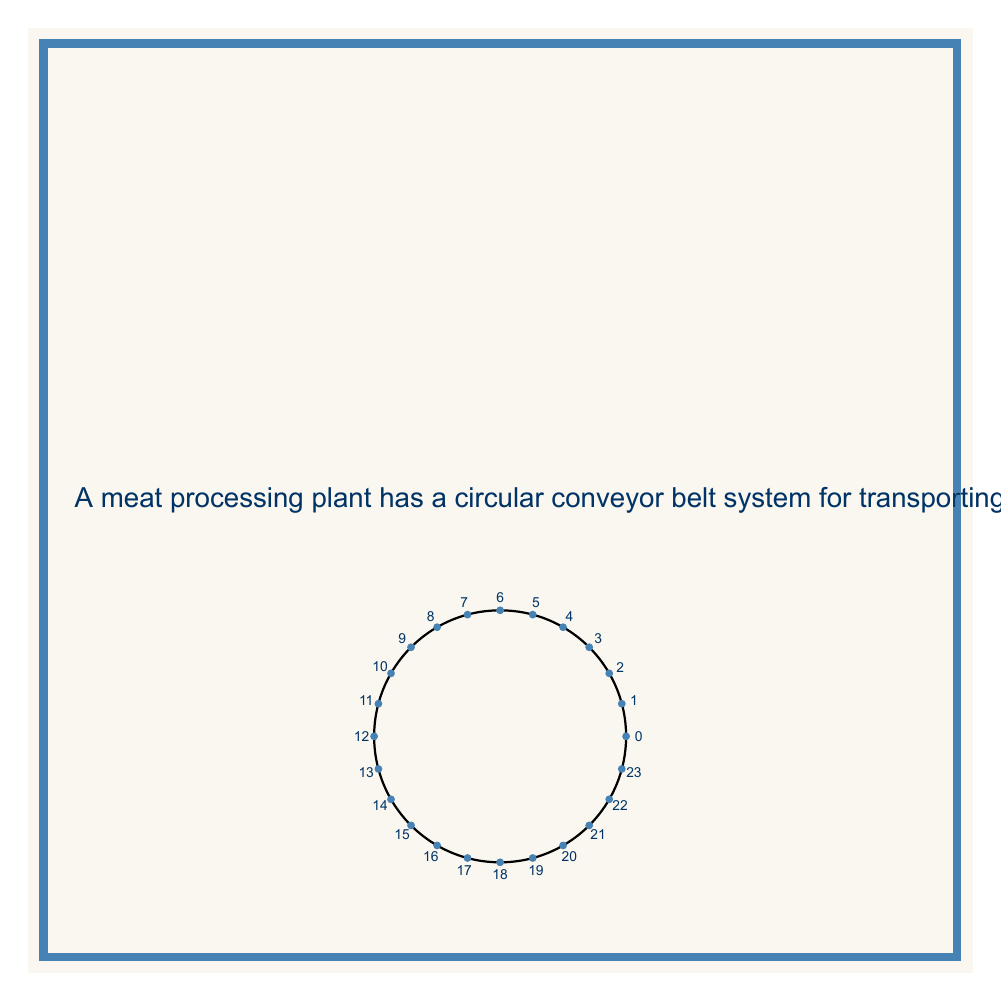What is the answer to this math problem? Let's approach this step-by-step:

1) First, we need to understand what a ring homomorphism does in this context. The function $f(x) = 5x \mod 24$ maps each station to another station in the ring.

2) To find the cycles, we need to repeatedly apply $f$ to each element until we return to the starting point.

3) Let's start with station 0:
   $f(0) = 0$, so 0 forms a cycle by itself.

4) For station 1:
   $f(1) = 5$
   $f(5) = 25 \mod 24 = 1$
   This forms a cycle (1, 5).

5) For station 2:
   $f(2) = 10$
   $f(10) = 50 \mod 24 = 2$
   This forms a cycle (2, 10).

6) For station 3:
   $f(3) = 15$
   $f(15) = 75 \mod 24 = 3$
   This forms a cycle (3, 15).

7) For station 4:
   $f(4) = 20$
   $f(20) = 100 \mod 24 = 4$
   This forms a cycle (4, 20).

8) For station 6:
   $f(6) = 30 \mod 24 = 6$
   This forms a cycle by itself.

9) For station 7:
   $f(7) = 35 \mod 24 = 11$
   $f(11) = 55 \mod 24 = 7$
   This forms a cycle (7, 11).

10) For station 8:
    $f(8) = 40 \mod 24 = 16$
    $f(16) = 80 \mod 24 = 8$
    This forms a cycle (8, 16).

11) For station 9:
    $f(9) = 45 \mod 24 = 21$
    $f(21) = 105 \mod 24 = 9$
    This forms a cycle (9, 21).

12) For station 12:
    $f(12) = 60 \mod 24 = 12$
    This forms a cycle by itself.

13) For station 13:
    $f(13) = 65 \mod 24 = 17$
    $f(17) = 85 \mod 24 = 13$
    This forms a cycle (13, 17).

14) For station 14:
    $f(14) = 70 \mod 24 = 22$
    $f(22) = 110 \mod 24 = 14$
    This forms a cycle (14, 22).

15) For station 18:
    $f(18) = 90 \mod 24 = 18$
    This forms a cycle by itself.

16) For station 19:
    $f(19) = 95 \mod 24 = 23$
    $f(23) = 115 \mod 24 = 19$
    This forms a cycle (19, 23).

We have now accounted for all 24 stations and found all distinct cycles.
Answer: 11 distinct cycles 